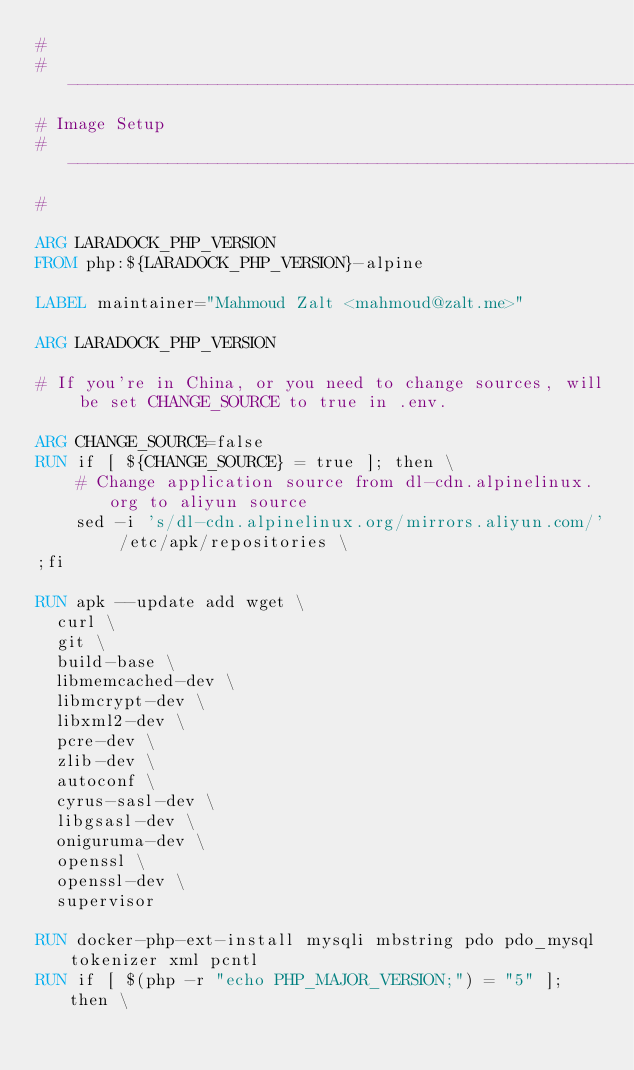Convert code to text. <code><loc_0><loc_0><loc_500><loc_500><_Dockerfile_>#
#--------------------------------------------------------------------------
# Image Setup
#--------------------------------------------------------------------------
#

ARG LARADOCK_PHP_VERSION
FROM php:${LARADOCK_PHP_VERSION}-alpine

LABEL maintainer="Mahmoud Zalt <mahmoud@zalt.me>"

ARG LARADOCK_PHP_VERSION

# If you're in China, or you need to change sources, will be set CHANGE_SOURCE to true in .env.

ARG CHANGE_SOURCE=false
RUN if [ ${CHANGE_SOURCE} = true ]; then \
    # Change application source from dl-cdn.alpinelinux.org to aliyun source
    sed -i 's/dl-cdn.alpinelinux.org/mirrors.aliyun.com/' /etc/apk/repositories \
;fi

RUN apk --update add wget \
  curl \
  git \
  build-base \
  libmemcached-dev \
  libmcrypt-dev \
  libxml2-dev \
  pcre-dev \
  zlib-dev \
  autoconf \
  cyrus-sasl-dev \
  libgsasl-dev \
  oniguruma-dev \
  openssl \
  openssl-dev \
  supervisor

RUN docker-php-ext-install mysqli mbstring pdo pdo_mysql tokenizer xml pcntl
RUN if [ $(php -r "echo PHP_MAJOR_VERSION;") = "5" ]; then \</code> 